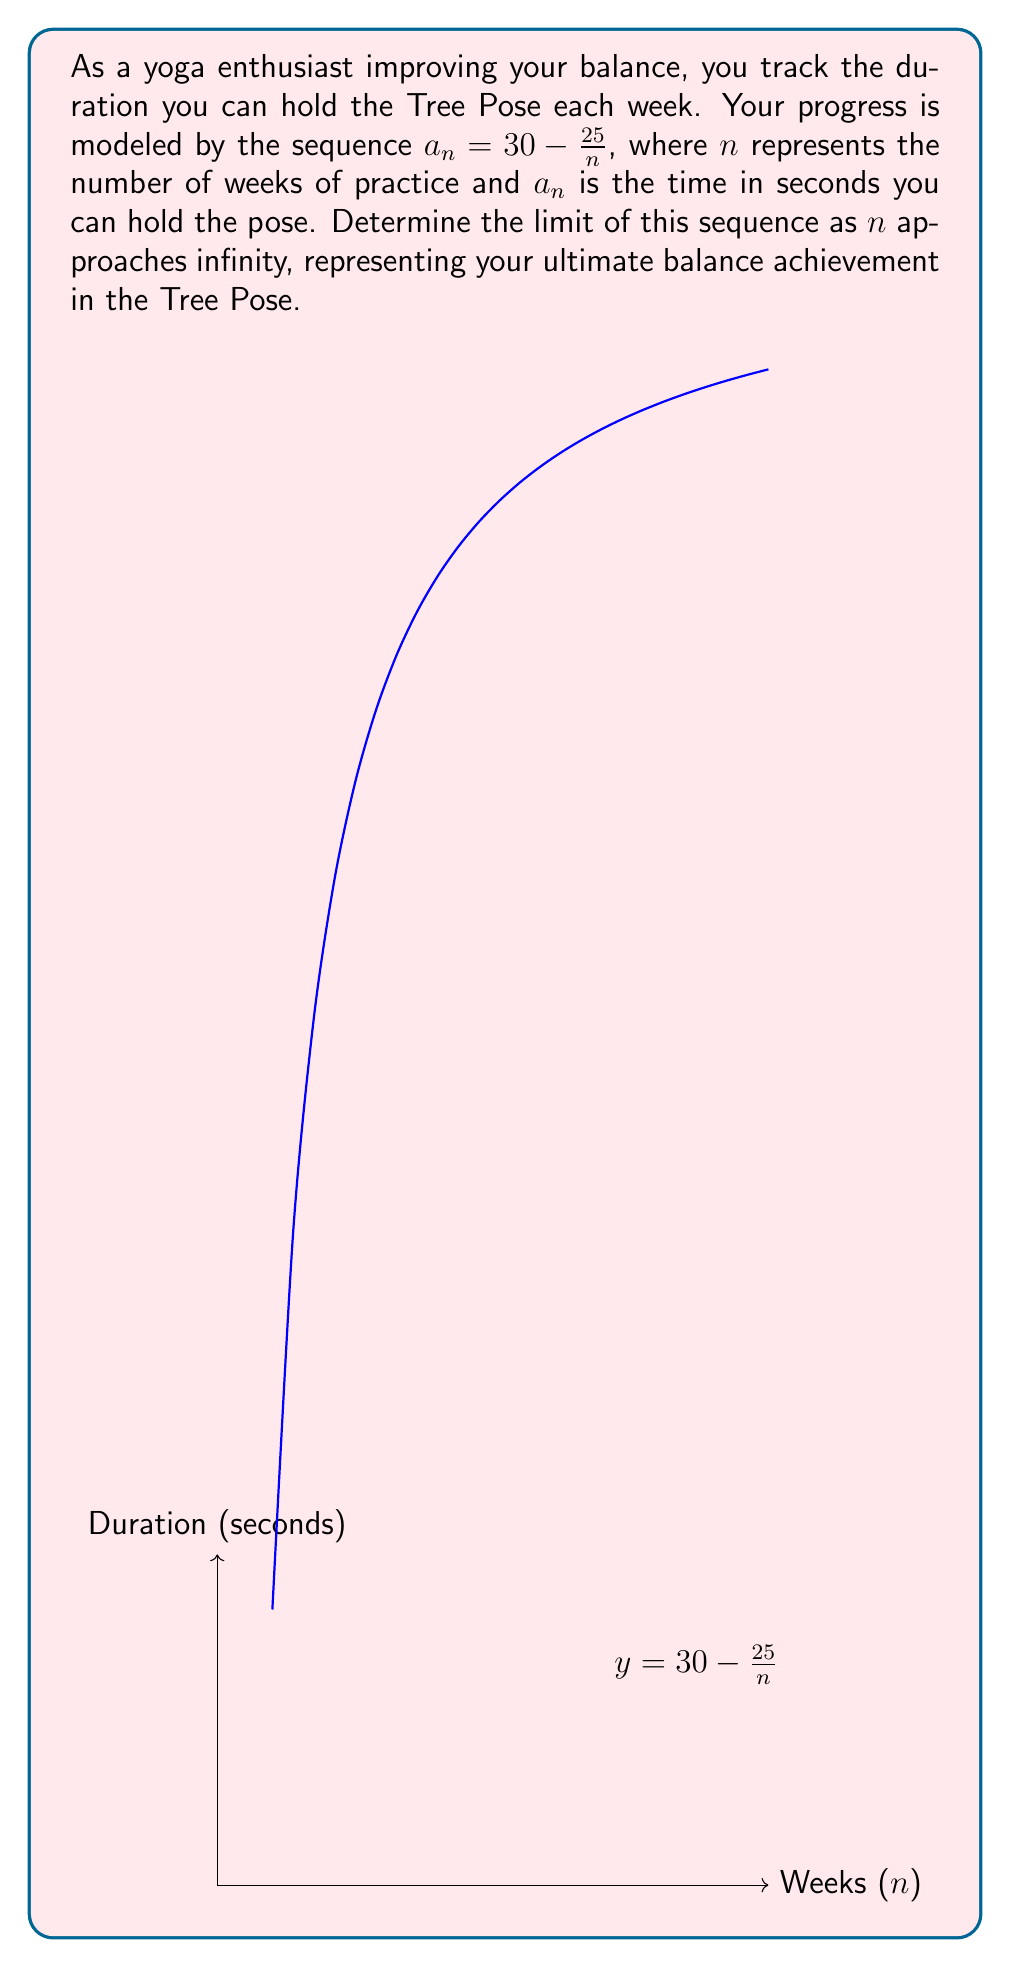Can you solve this math problem? Let's approach this step-by-step:

1) We're given the sequence $a_n = 30 - \frac{25}{n}$.

2) To find the limit as $n$ approaches infinity, we need to evaluate:

   $$\lim_{n \to \infty} (30 - \frac{25}{n})$$

3) We can separate this into two parts:

   $$\lim_{n \to \infty} 30 - \lim_{n \to \infty} \frac{25}{n}$$

4) The first part is simple: $\lim_{n \to \infty} 30 = 30$

5) For the second part:
   $$\lim_{n \to \infty} \frac{25}{n} = 25 \cdot \lim_{n \to \infty} \frac{1}{n} = 25 \cdot 0 = 0$$

   As $n$ grows infinitely large, $\frac{1}{n}$ approaches 0.

6) Putting it back together:

   $$\lim_{n \to \infty} (30 - \frac{25}{n}) = 30 - 0 = 30$$

Therefore, as you continue practicing, your balance in the Tree Pose approaches a limit of 30 seconds.
Answer: $30$ seconds 